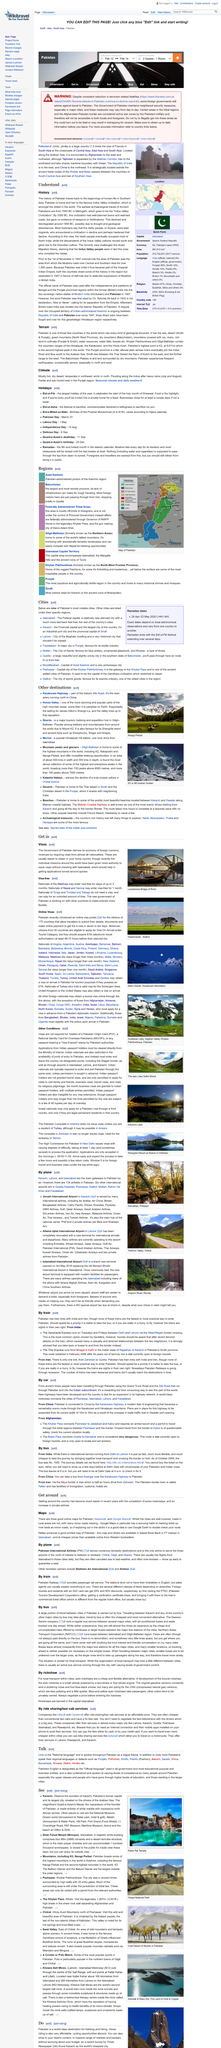Point out several critical features in this image. Yes, the Samjhauta Express originates from India. The Federally Administered Tribal Areas is mostly off limits to foreigners. The Indus Valley civilization was a thriving culture that flourished in what is now Pakistan. This ancient civilization, also known as the Harappan civilization, developed in the region from approximately 2600 BCE to 1900 BCE. During this time, the Indus Valley civilization created sophisticated cities with well-planned streets, drainage systems, and public buildings. They also developed a writing system, trade networks, and a diverse range of crafts and industries. The Indus Valley civilization was a significant cultural and technological achievement in the ancient history of South Asia. Nanga Parbat, the ninth highest mountain in the world, is visually depicted in the given picture. Karachi is Pakistan's largest city, and it is evident from the fact that... 